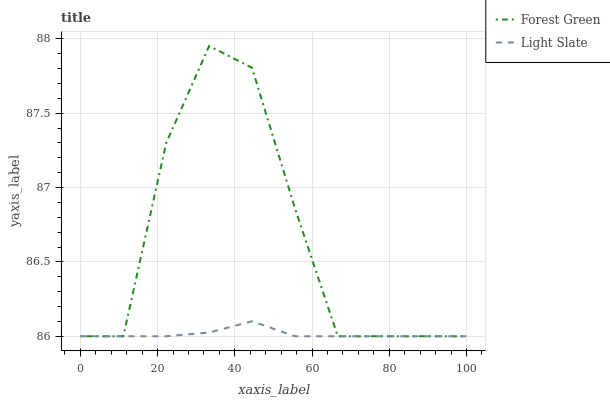Does Light Slate have the minimum area under the curve?
Answer yes or no. Yes. Does Forest Green have the maximum area under the curve?
Answer yes or no. Yes. Does Forest Green have the minimum area under the curve?
Answer yes or no. No. Is Light Slate the smoothest?
Answer yes or no. Yes. Is Forest Green the roughest?
Answer yes or no. Yes. Is Forest Green the smoothest?
Answer yes or no. No. Does Forest Green have the highest value?
Answer yes or no. Yes. Does Light Slate intersect Forest Green?
Answer yes or no. Yes. Is Light Slate less than Forest Green?
Answer yes or no. No. Is Light Slate greater than Forest Green?
Answer yes or no. No. 